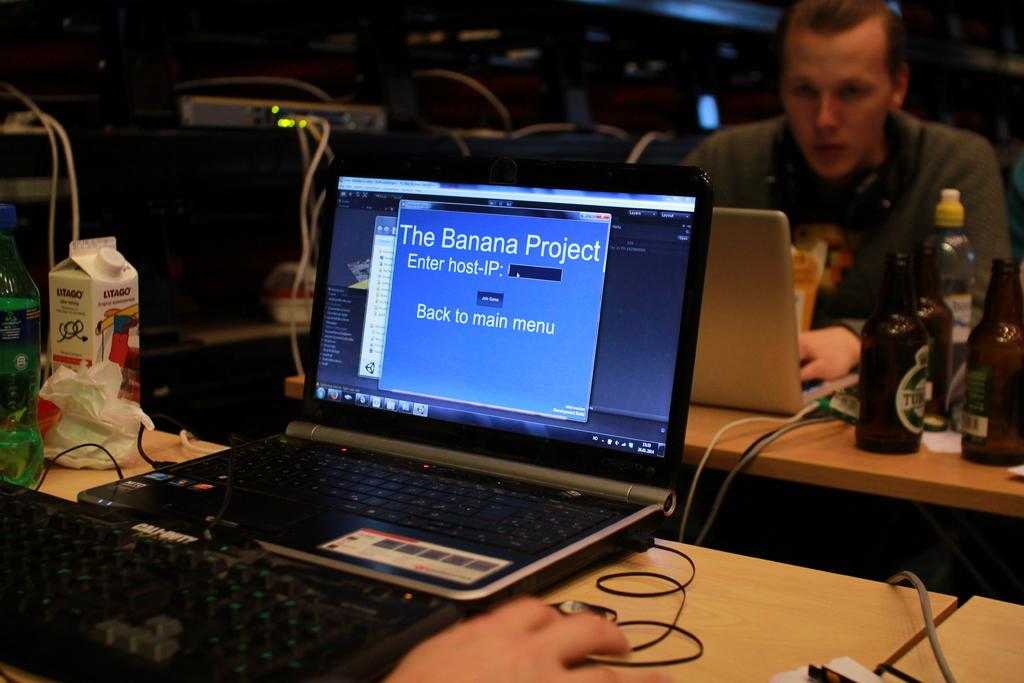<image>
Write a terse but informative summary of the picture. A laptop sits on a table with the words The Banana Project, written on the screen. 